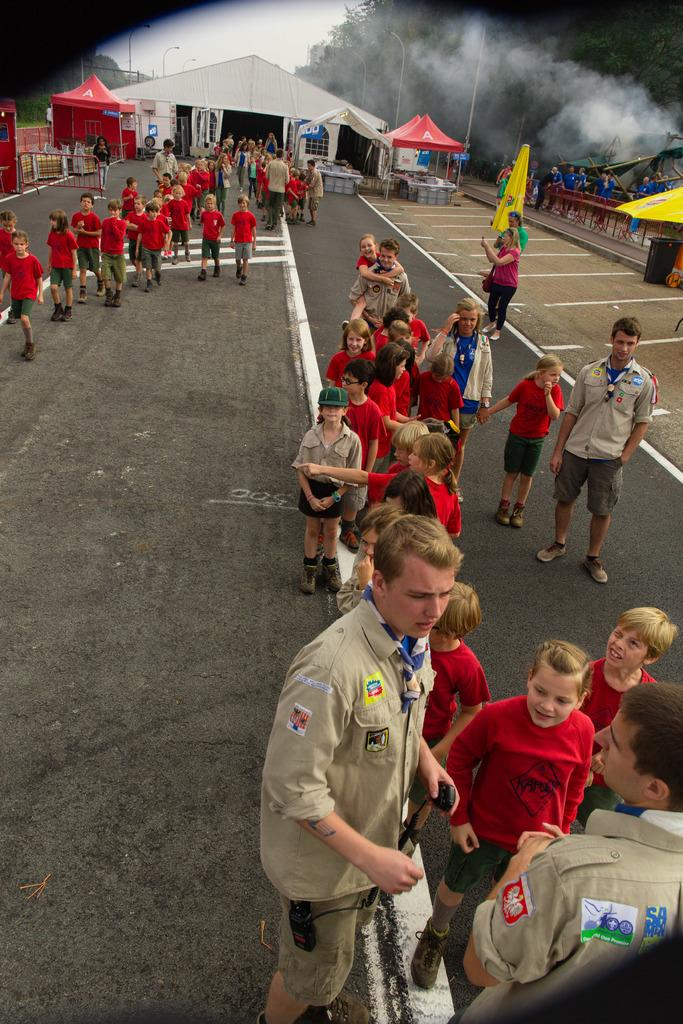What is happening in the image? There are many people standing on the road. What can be seen in the background of the image? There are tents, poles, and trees in the background of the image. Can you describe the presence of smoke in the image? Yes, there is smoke visible in the image. What is the son's favorite hobby in the image? There is no mention of a son or any specific individual in the image, so we cannot determine their favorite hobby. 